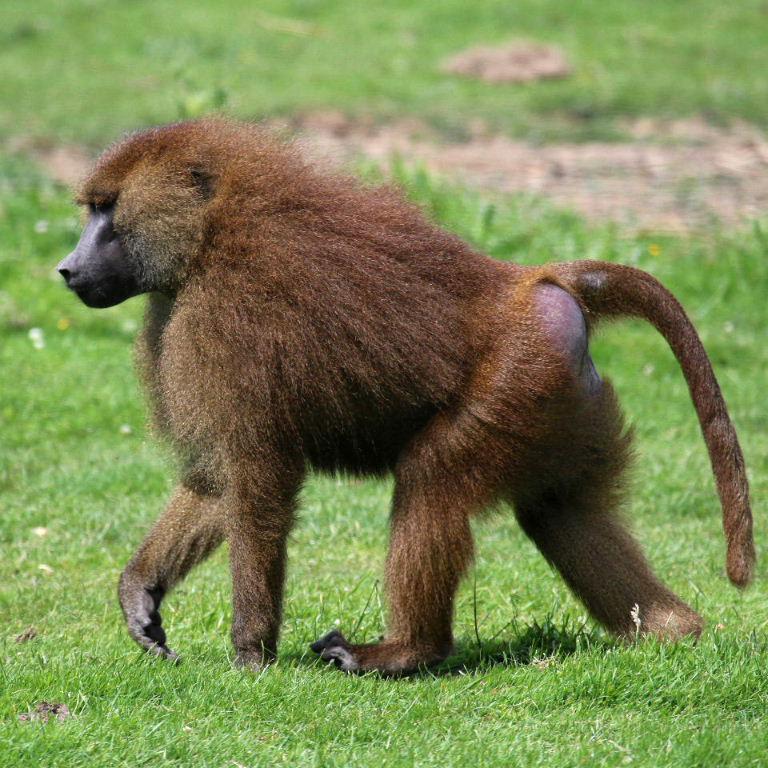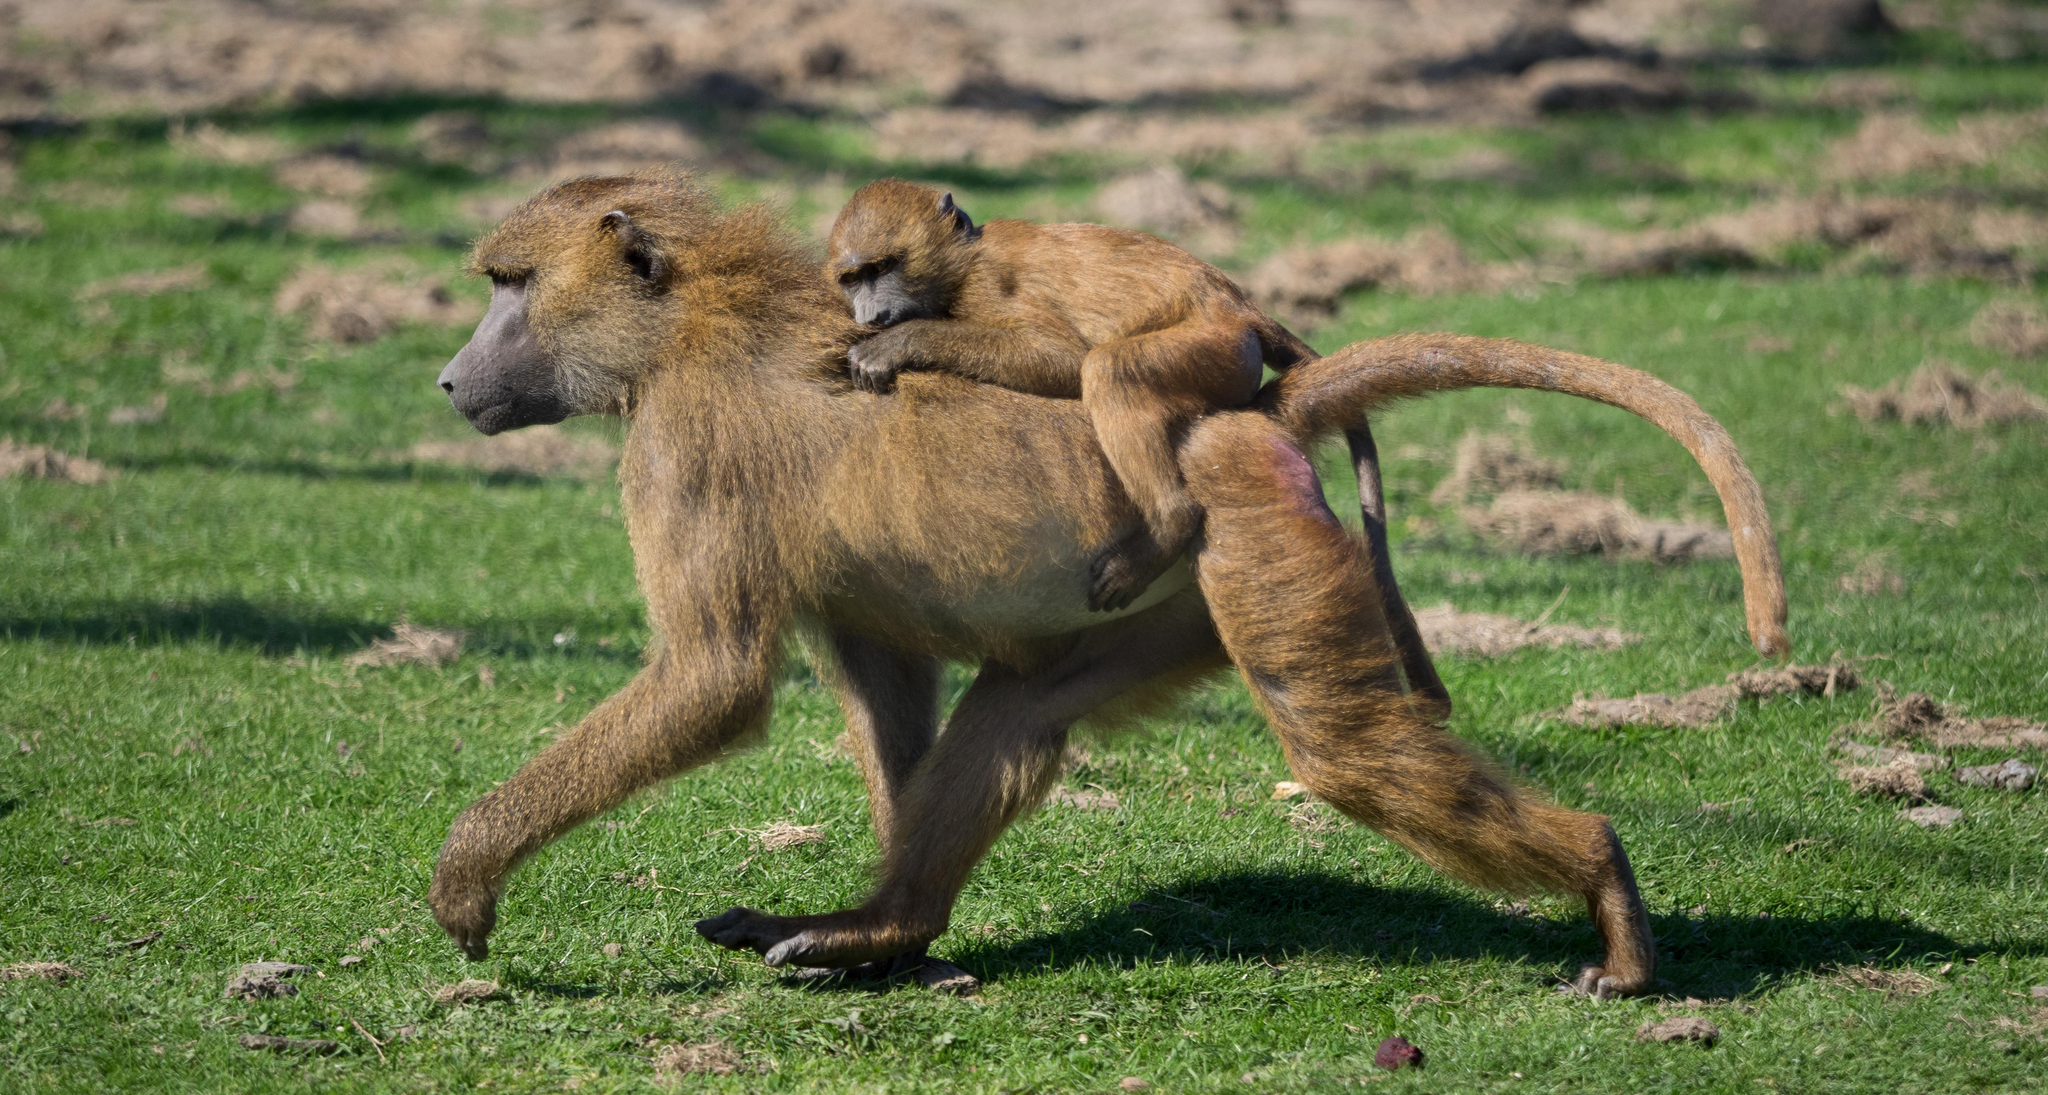The first image is the image on the left, the second image is the image on the right. For the images shown, is this caption "An image shows a baby baboon clinging, with its body pressed flat, to the back of an adult baboon walking on all fours." true? Answer yes or no. Yes. The first image is the image on the left, the second image is the image on the right. Considering the images on both sides, is "The right image contains no more than one baboon." valid? Answer yes or no. No. 